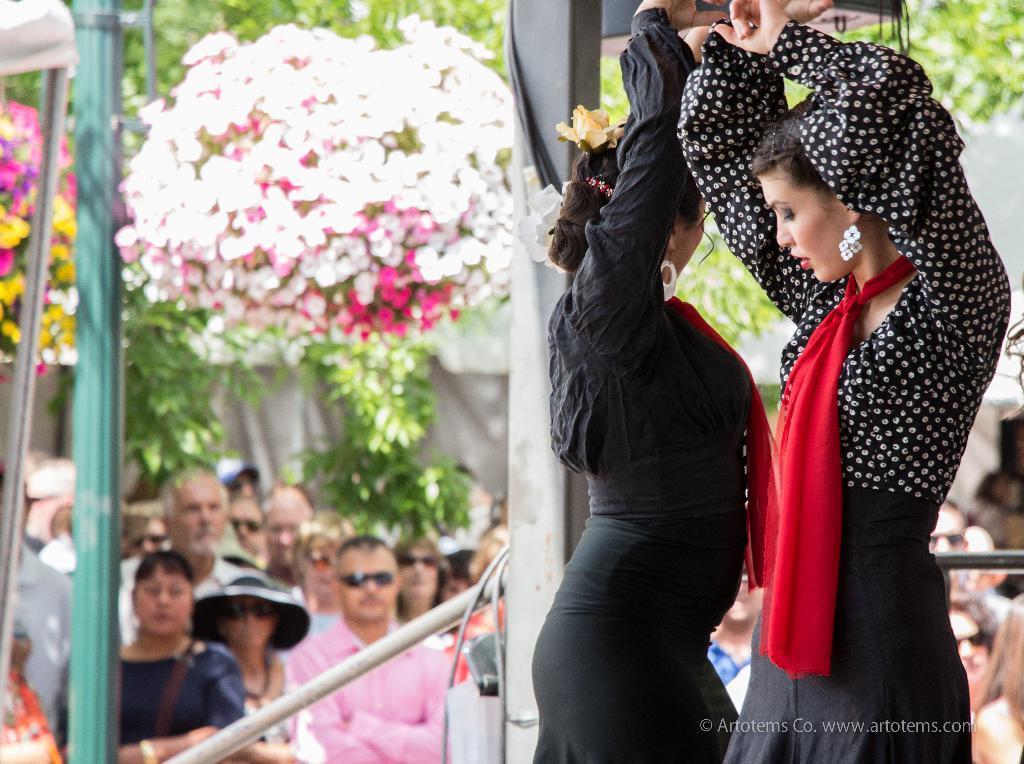Describe this image in one or two sentences. In the foreground of this image, there are two women and it seems like they are dancing and behind them, there is a pole and few people standing and watching them. We can also see flowers, poles, trees and the wall. 